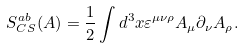<formula> <loc_0><loc_0><loc_500><loc_500>S _ { C S } ^ { a b } ( A ) = \frac { 1 } { 2 } \int d ^ { 3 } x \varepsilon ^ { \mu \nu \rho } A _ { \mu } \partial _ { \nu } A _ { \rho } .</formula> 